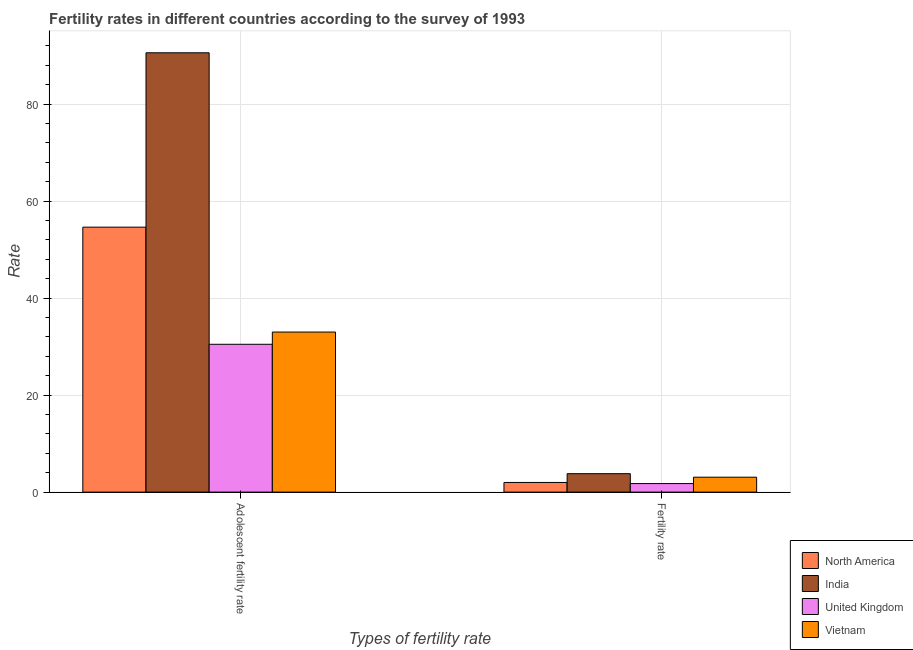How many groups of bars are there?
Offer a very short reply. 2. Are the number of bars per tick equal to the number of legend labels?
Ensure brevity in your answer.  Yes. Are the number of bars on each tick of the X-axis equal?
Provide a succinct answer. Yes. How many bars are there on the 2nd tick from the right?
Your answer should be compact. 4. What is the label of the 2nd group of bars from the left?
Offer a very short reply. Fertility rate. What is the fertility rate in Vietnam?
Your response must be concise. 3.07. Across all countries, what is the maximum adolescent fertility rate?
Make the answer very short. 90.57. Across all countries, what is the minimum adolescent fertility rate?
Provide a short and direct response. 30.47. In which country was the adolescent fertility rate maximum?
Your response must be concise. India. What is the total fertility rate in the graph?
Give a very brief answer. 10.62. What is the difference between the adolescent fertility rate in India and that in Vietnam?
Provide a succinct answer. 57.57. What is the difference between the adolescent fertility rate in United Kingdom and the fertility rate in Vietnam?
Ensure brevity in your answer.  27.4. What is the average fertility rate per country?
Offer a very short reply. 2.65. What is the difference between the fertility rate and adolescent fertility rate in North America?
Keep it short and to the point. -52.63. In how many countries, is the adolescent fertility rate greater than 60 ?
Your response must be concise. 1. What is the ratio of the adolescent fertility rate in North America to that in United Kingdom?
Provide a short and direct response. 1.79. What does the 1st bar from the right in Fertility rate represents?
Provide a succinct answer. Vietnam. How many bars are there?
Ensure brevity in your answer.  8. Are all the bars in the graph horizontal?
Ensure brevity in your answer.  No. Are the values on the major ticks of Y-axis written in scientific E-notation?
Your answer should be compact. No. What is the title of the graph?
Keep it short and to the point. Fertility rates in different countries according to the survey of 1993. What is the label or title of the X-axis?
Make the answer very short. Types of fertility rate. What is the label or title of the Y-axis?
Provide a succinct answer. Rate. What is the Rate of North America in Adolescent fertility rate?
Your response must be concise. 54.62. What is the Rate in India in Adolescent fertility rate?
Offer a terse response. 90.57. What is the Rate of United Kingdom in Adolescent fertility rate?
Make the answer very short. 30.47. What is the Rate in Vietnam in Adolescent fertility rate?
Your response must be concise. 33. What is the Rate in North America in Fertility rate?
Make the answer very short. 1.99. What is the Rate in India in Fertility rate?
Offer a terse response. 3.8. What is the Rate in United Kingdom in Fertility rate?
Keep it short and to the point. 1.76. What is the Rate in Vietnam in Fertility rate?
Provide a short and direct response. 3.07. Across all Types of fertility rate, what is the maximum Rate of North America?
Your response must be concise. 54.62. Across all Types of fertility rate, what is the maximum Rate of India?
Your response must be concise. 90.57. Across all Types of fertility rate, what is the maximum Rate of United Kingdom?
Make the answer very short. 30.47. Across all Types of fertility rate, what is the maximum Rate of Vietnam?
Your answer should be very brief. 33. Across all Types of fertility rate, what is the minimum Rate of North America?
Offer a very short reply. 1.99. Across all Types of fertility rate, what is the minimum Rate in India?
Offer a very short reply. 3.8. Across all Types of fertility rate, what is the minimum Rate in United Kingdom?
Give a very brief answer. 1.76. Across all Types of fertility rate, what is the minimum Rate in Vietnam?
Ensure brevity in your answer.  3.07. What is the total Rate in North America in the graph?
Your response must be concise. 56.61. What is the total Rate of India in the graph?
Provide a short and direct response. 94.37. What is the total Rate in United Kingdom in the graph?
Your response must be concise. 32.23. What is the total Rate of Vietnam in the graph?
Make the answer very short. 36.07. What is the difference between the Rate in North America in Adolescent fertility rate and that in Fertility rate?
Provide a succinct answer. 52.63. What is the difference between the Rate of India in Adolescent fertility rate and that in Fertility rate?
Give a very brief answer. 86.77. What is the difference between the Rate in United Kingdom in Adolescent fertility rate and that in Fertility rate?
Provide a short and direct response. 28.71. What is the difference between the Rate of Vietnam in Adolescent fertility rate and that in Fertility rate?
Give a very brief answer. 29.92. What is the difference between the Rate of North America in Adolescent fertility rate and the Rate of India in Fertility rate?
Your answer should be very brief. 50.82. What is the difference between the Rate of North America in Adolescent fertility rate and the Rate of United Kingdom in Fertility rate?
Provide a short and direct response. 52.86. What is the difference between the Rate of North America in Adolescent fertility rate and the Rate of Vietnam in Fertility rate?
Your response must be concise. 51.55. What is the difference between the Rate of India in Adolescent fertility rate and the Rate of United Kingdom in Fertility rate?
Make the answer very short. 88.81. What is the difference between the Rate in India in Adolescent fertility rate and the Rate in Vietnam in Fertility rate?
Offer a very short reply. 87.49. What is the difference between the Rate of United Kingdom in Adolescent fertility rate and the Rate of Vietnam in Fertility rate?
Ensure brevity in your answer.  27.4. What is the average Rate of North America per Types of fertility rate?
Make the answer very short. 28.3. What is the average Rate in India per Types of fertility rate?
Offer a very short reply. 47.18. What is the average Rate in United Kingdom per Types of fertility rate?
Make the answer very short. 16.12. What is the average Rate in Vietnam per Types of fertility rate?
Offer a terse response. 18.04. What is the difference between the Rate of North America and Rate of India in Adolescent fertility rate?
Your response must be concise. -35.95. What is the difference between the Rate in North America and Rate in United Kingdom in Adolescent fertility rate?
Keep it short and to the point. 24.15. What is the difference between the Rate in North America and Rate in Vietnam in Adolescent fertility rate?
Your answer should be compact. 21.63. What is the difference between the Rate in India and Rate in United Kingdom in Adolescent fertility rate?
Offer a terse response. 60.09. What is the difference between the Rate in India and Rate in Vietnam in Adolescent fertility rate?
Provide a succinct answer. 57.57. What is the difference between the Rate in United Kingdom and Rate in Vietnam in Adolescent fertility rate?
Keep it short and to the point. -2.52. What is the difference between the Rate in North America and Rate in India in Fertility rate?
Your response must be concise. -1.81. What is the difference between the Rate in North America and Rate in United Kingdom in Fertility rate?
Your answer should be very brief. 0.23. What is the difference between the Rate of North America and Rate of Vietnam in Fertility rate?
Ensure brevity in your answer.  -1.09. What is the difference between the Rate of India and Rate of United Kingdom in Fertility rate?
Your answer should be compact. 2.04. What is the difference between the Rate of India and Rate of Vietnam in Fertility rate?
Offer a very short reply. 0.72. What is the difference between the Rate in United Kingdom and Rate in Vietnam in Fertility rate?
Ensure brevity in your answer.  -1.31. What is the ratio of the Rate in North America in Adolescent fertility rate to that in Fertility rate?
Your response must be concise. 27.49. What is the ratio of the Rate of India in Adolescent fertility rate to that in Fertility rate?
Make the answer very short. 23.85. What is the ratio of the Rate of United Kingdom in Adolescent fertility rate to that in Fertility rate?
Keep it short and to the point. 17.31. What is the ratio of the Rate in Vietnam in Adolescent fertility rate to that in Fertility rate?
Keep it short and to the point. 10.73. What is the difference between the highest and the second highest Rate in North America?
Keep it short and to the point. 52.63. What is the difference between the highest and the second highest Rate of India?
Ensure brevity in your answer.  86.77. What is the difference between the highest and the second highest Rate in United Kingdom?
Your response must be concise. 28.71. What is the difference between the highest and the second highest Rate in Vietnam?
Provide a succinct answer. 29.92. What is the difference between the highest and the lowest Rate of North America?
Provide a short and direct response. 52.63. What is the difference between the highest and the lowest Rate in India?
Give a very brief answer. 86.77. What is the difference between the highest and the lowest Rate in United Kingdom?
Make the answer very short. 28.71. What is the difference between the highest and the lowest Rate of Vietnam?
Provide a succinct answer. 29.92. 